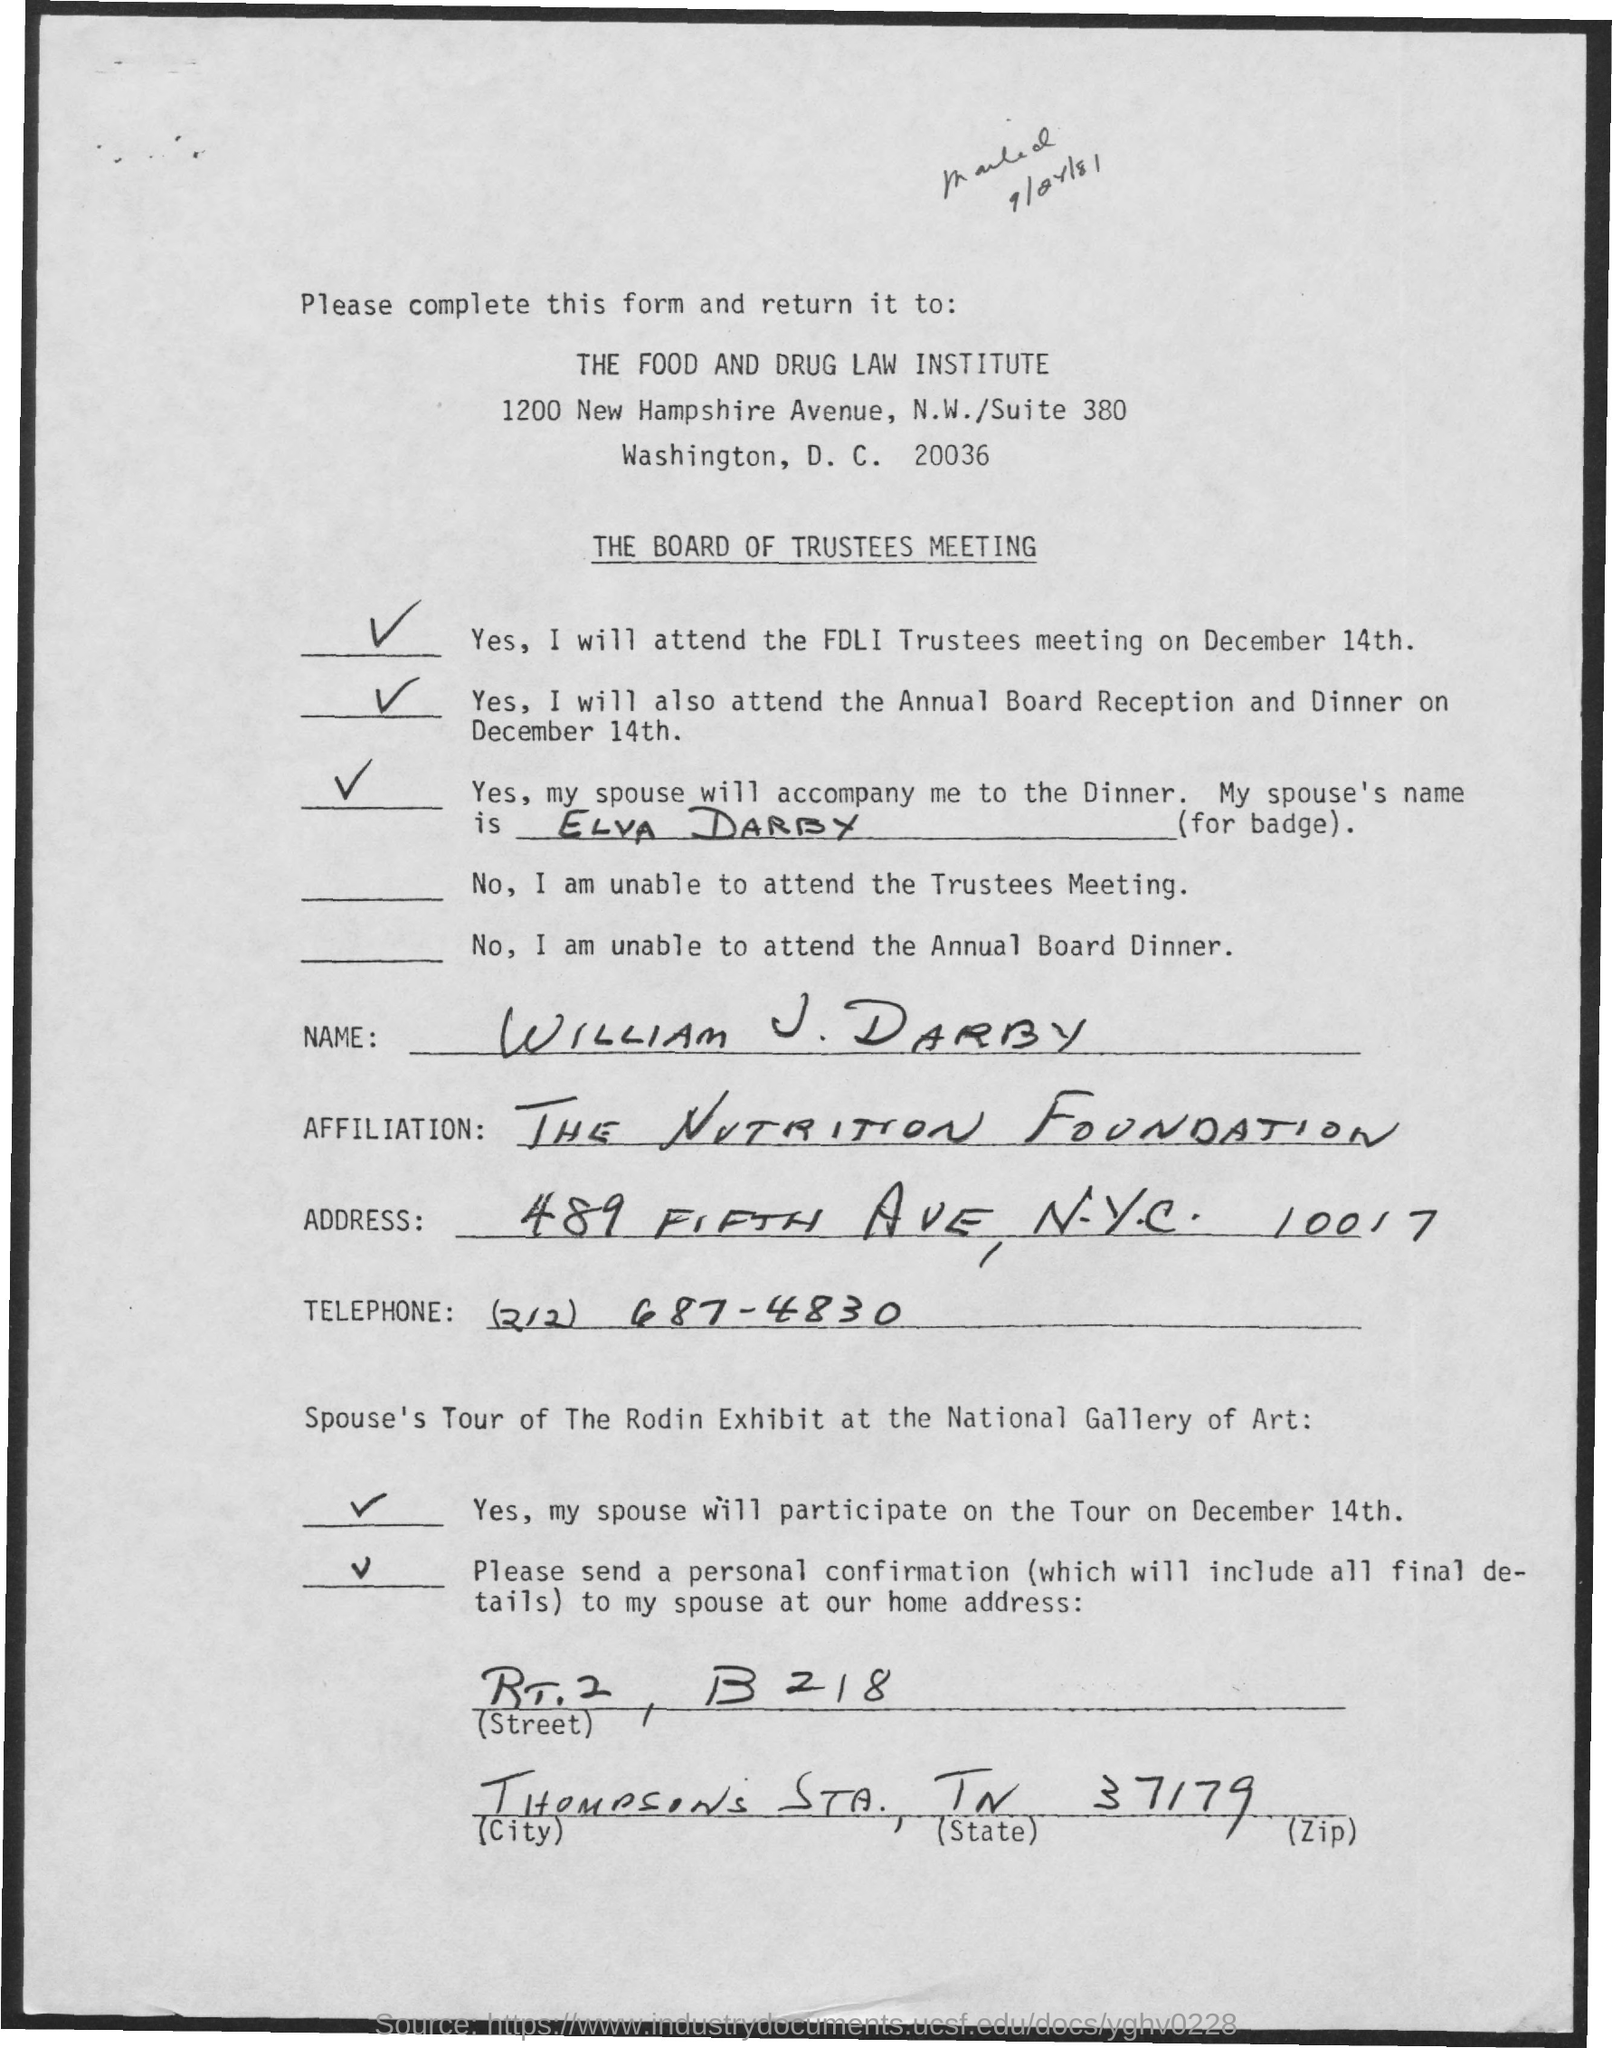To which institute the filled form shall be sent?
Your response must be concise. THE FOOD AND DRUG LAW INSTITUTE. Where to return the form?
Your answer should be compact. THE FOOD AND DRUG LAW INSTITUTE. For which meeting is this form?
Offer a terse response. The fdli trustees meeting. Who was accompanying mr. willam j. darby
Your answer should be compact. ELVA DARBY. What is WILLAM'S AFFILIATION?
Give a very brief answer. THE NUTRITION FOUNDATION. 